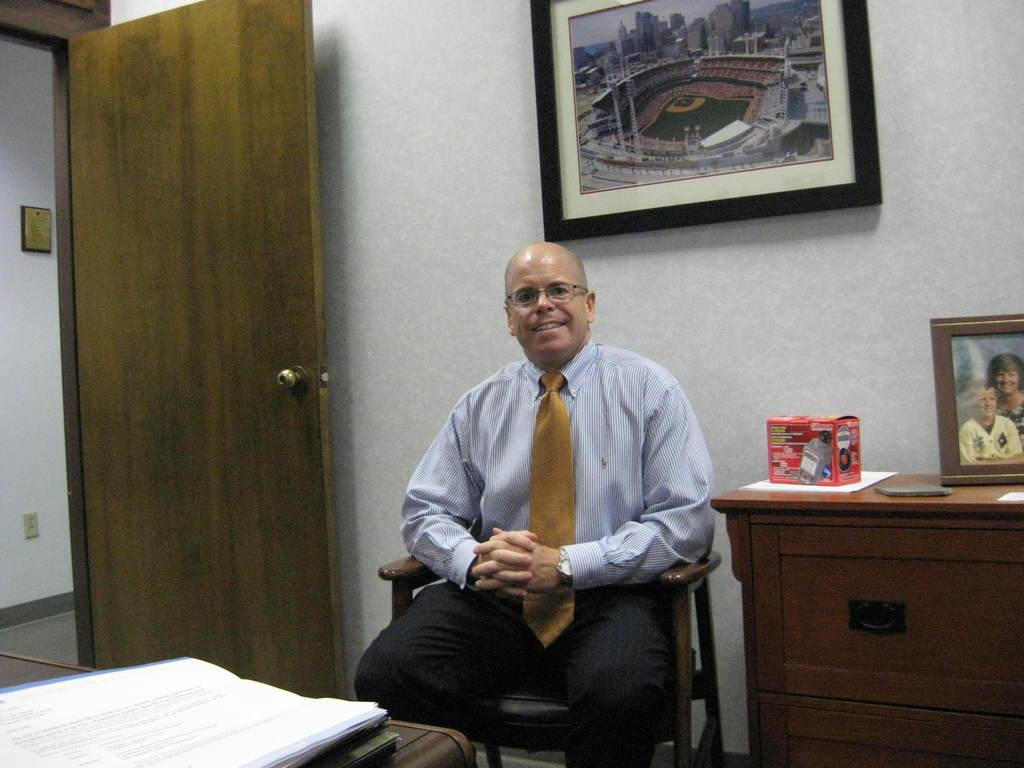What is the man in the image doing? The man is sitting in a chair. What can be seen in the background of the image? There is a cardboard, a photo frame, a box, paper, a frame attached to the wall, and a door in the background. Can you describe the objects in the background? The background features a cardboard, a photo frame, a box, paper, a frame attached to the wall, and a door. What type of eggs can be seen in the image? There are no eggs present in the image. What appliance is being used by the man in the image? There is no appliance visible in the image; the man is simply sitting in a chair. 